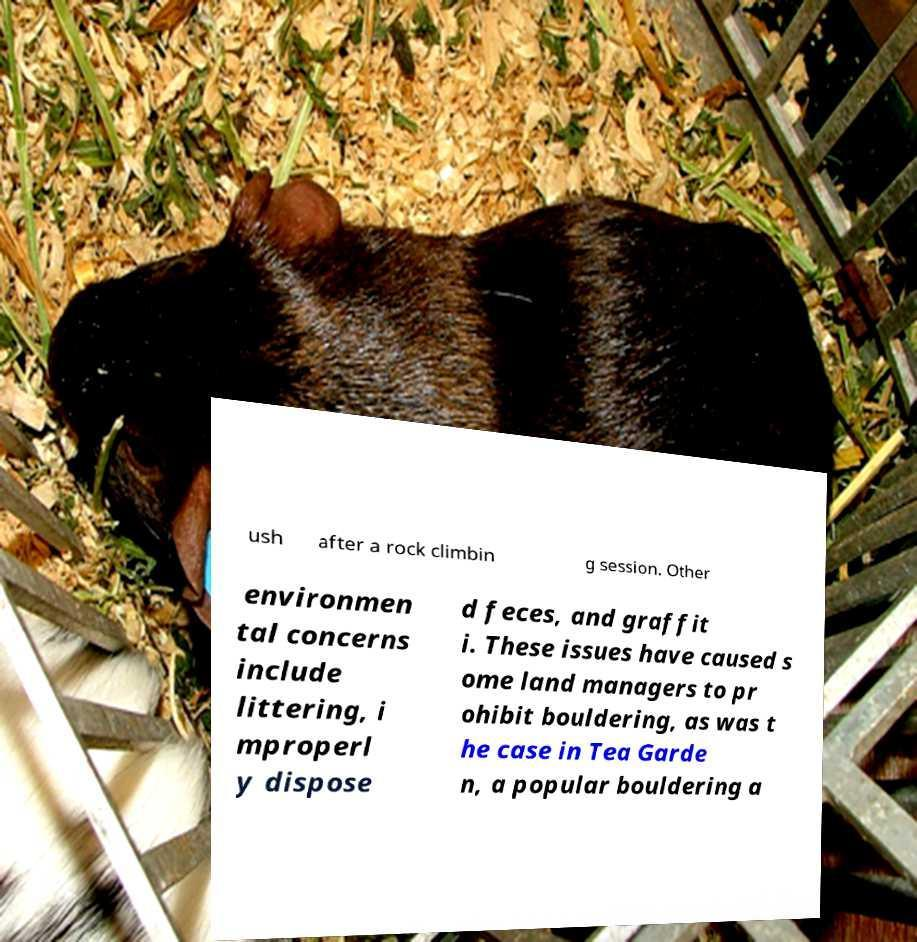I need the written content from this picture converted into text. Can you do that? ush after a rock climbin g session. Other environmen tal concerns include littering, i mproperl y dispose d feces, and graffit i. These issues have caused s ome land managers to pr ohibit bouldering, as was t he case in Tea Garde n, a popular bouldering a 